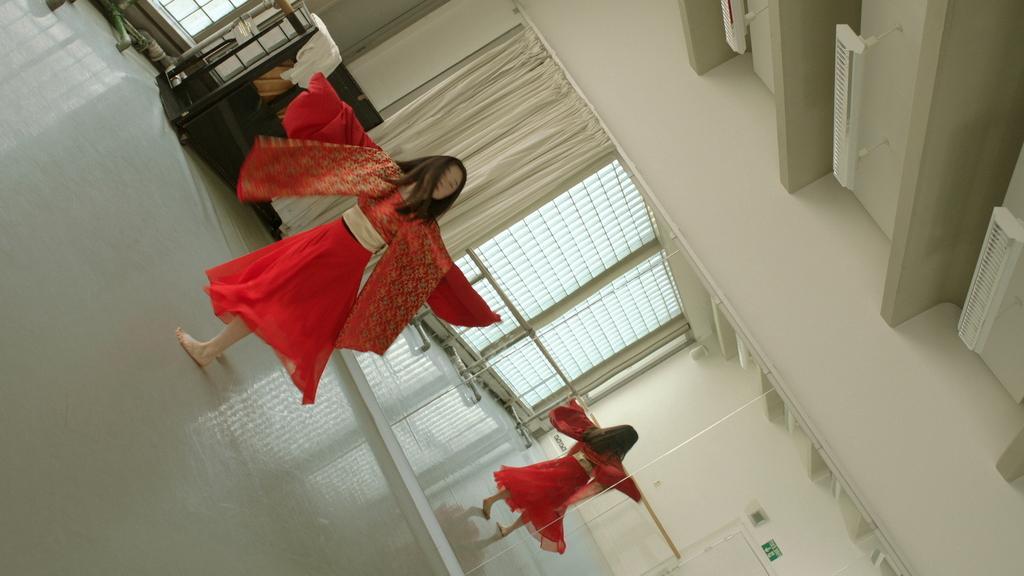Can you describe this image briefly? In the picture we can see a woman dancing on the floor of a hall, she is in a red dress and behind her we can see the mirror and beside it, we can see a curtain and in the mirror, we can see the reflection of a woman and a window and beside the mirror we can see a small cupboard and on it we can see some clothes and beside it we can see a part of the window. 